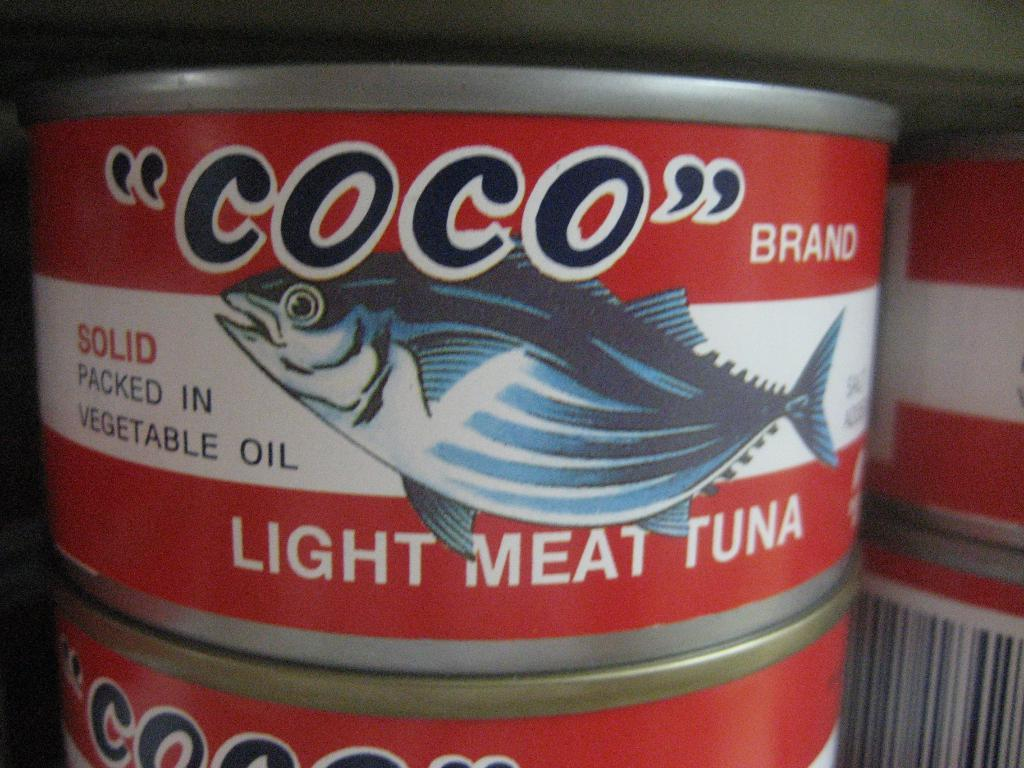<image>
Summarize the visual content of the image. a light meat tuna can is on top of another 